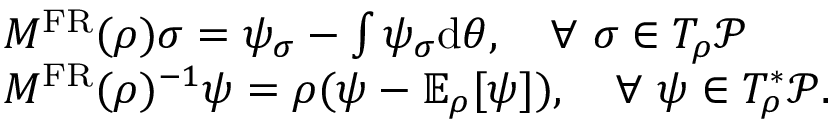<formula> <loc_0><loc_0><loc_500><loc_500>\begin{array} { r l } & { M ^ { F R } ( \rho ) \sigma = \psi _ { \sigma } - \int \psi _ { \sigma } d \theta , \quad \forall \sigma \in T _ { \rho } \mathcal { P } } \\ & { M ^ { F R } ( \rho ) ^ { - 1 } \psi = \rho ( \psi - \mathbb { E } _ { \rho } [ \psi ] ) , \quad \forall \psi \in T _ { \rho } ^ { * } \mathcal { P } . } \end{array}</formula> 